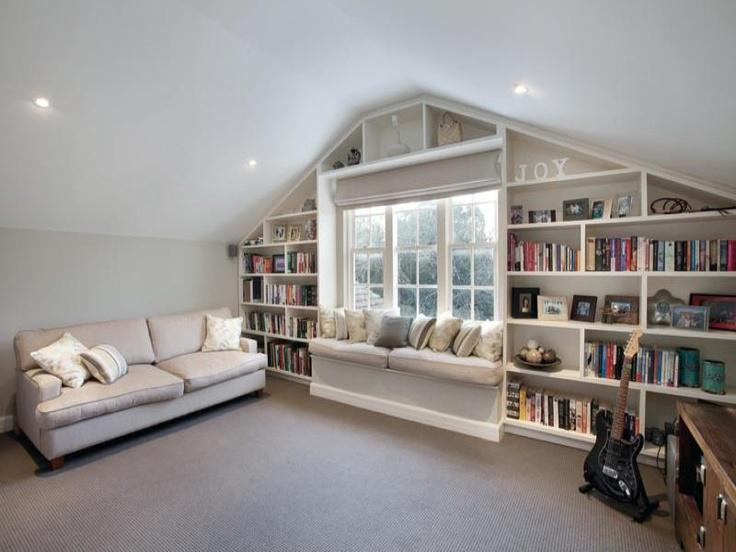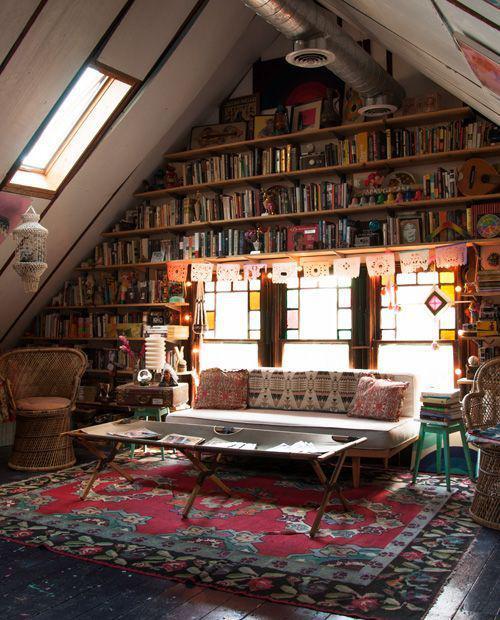The first image is the image on the left, the second image is the image on the right. Evaluate the accuracy of this statement regarding the images: "An image shows a square skylight in the peaked ceiling of a room with shelves along the wall.". Is it true? Answer yes or no. Yes. The first image is the image on the left, the second image is the image on the right. Considering the images on both sides, is "In one image, a couch with throw pillows, a coffee table and at least one side chair form a seating area in front of a wall of bookshelves." valid? Answer yes or no. Yes. 